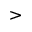<formula> <loc_0><loc_0><loc_500><loc_500>></formula> 